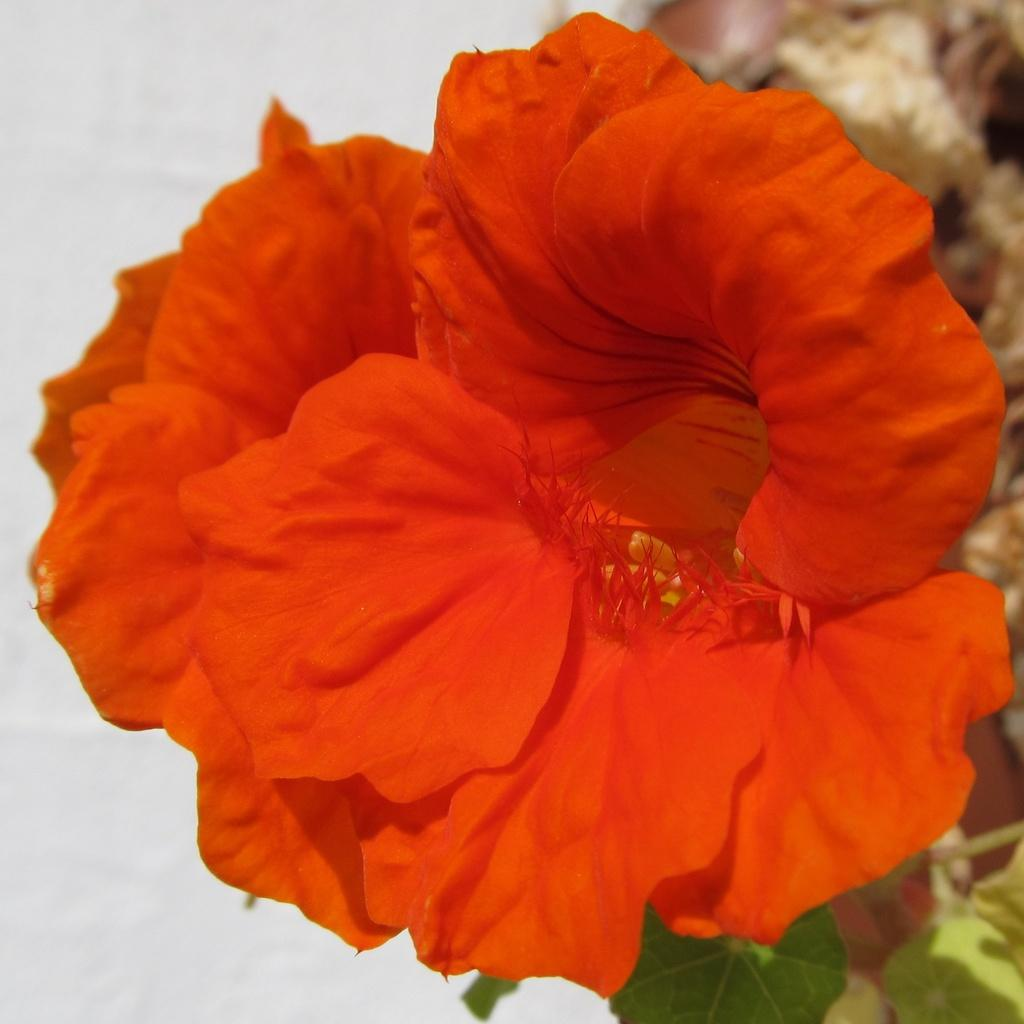What type of plants can be seen in the image? There are flowers and leaves in the image. What color is the background of the image? The background of the image is white. What type of toys can be seen on the floor in the image? There are no toys or floor present in the image; it only features flowers and leaves against a white background. 